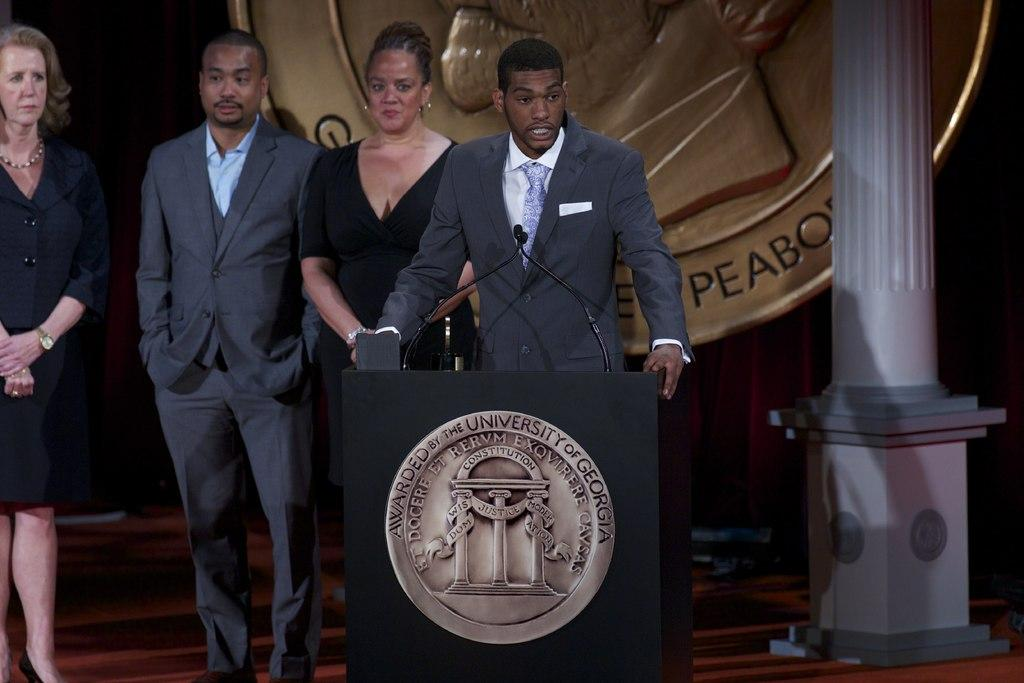<image>
Relay a brief, clear account of the picture shown. The speakers stand behind a podium that has a sign that says awarded by the University of Georgia. 